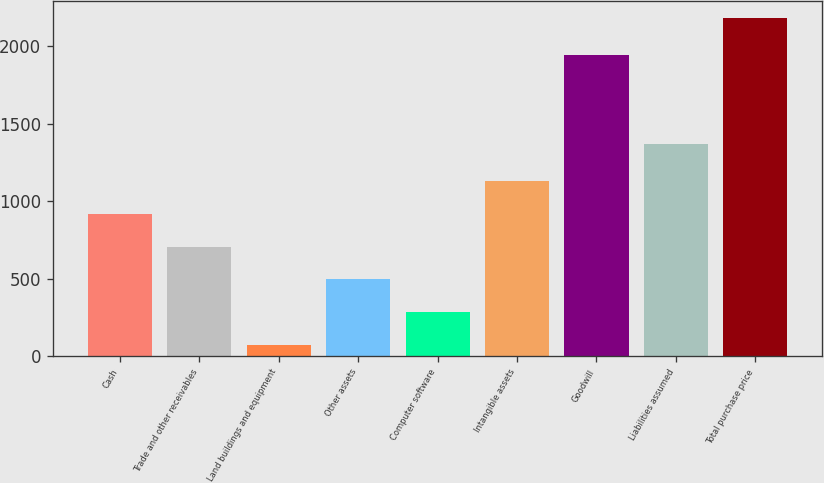Convert chart. <chart><loc_0><loc_0><loc_500><loc_500><bar_chart><fcel>Cash<fcel>Trade and other receivables<fcel>Land buildings and equipment<fcel>Other assets<fcel>Computer software<fcel>Intangible assets<fcel>Goodwill<fcel>Liabilities assumed<fcel>Total purchase price<nl><fcel>915.88<fcel>705.01<fcel>72.4<fcel>494.14<fcel>283.27<fcel>1126.75<fcel>1939.8<fcel>1370.6<fcel>2181.1<nl></chart> 